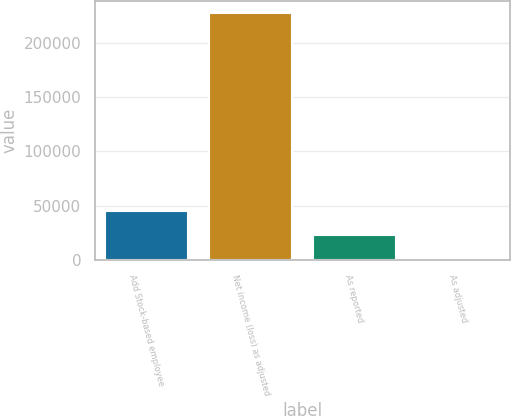Convert chart to OTSL. <chart><loc_0><loc_0><loc_500><loc_500><bar_chart><fcel>Add Stock-based employee<fcel>Net income (loss) as adjusted<fcel>As reported<fcel>As adjusted<nl><fcel>45446.5<fcel>227229<fcel>22723.7<fcel>0.85<nl></chart> 